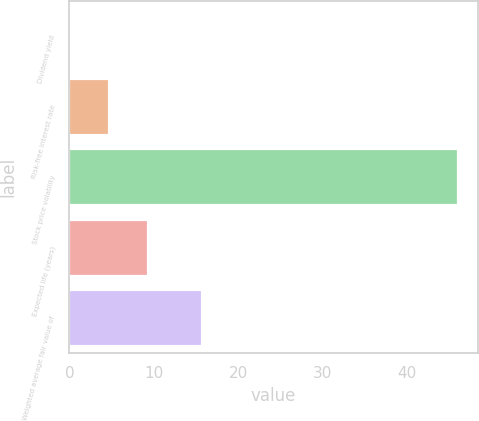Convert chart to OTSL. <chart><loc_0><loc_0><loc_500><loc_500><bar_chart><fcel>Dividend yield<fcel>Risk-free interest rate<fcel>Stock price volatility<fcel>Expected life (years)<fcel>Weighted average fair value of<nl><fcel>0.1<fcel>4.7<fcel>46.1<fcel>9.3<fcel>15.69<nl></chart> 